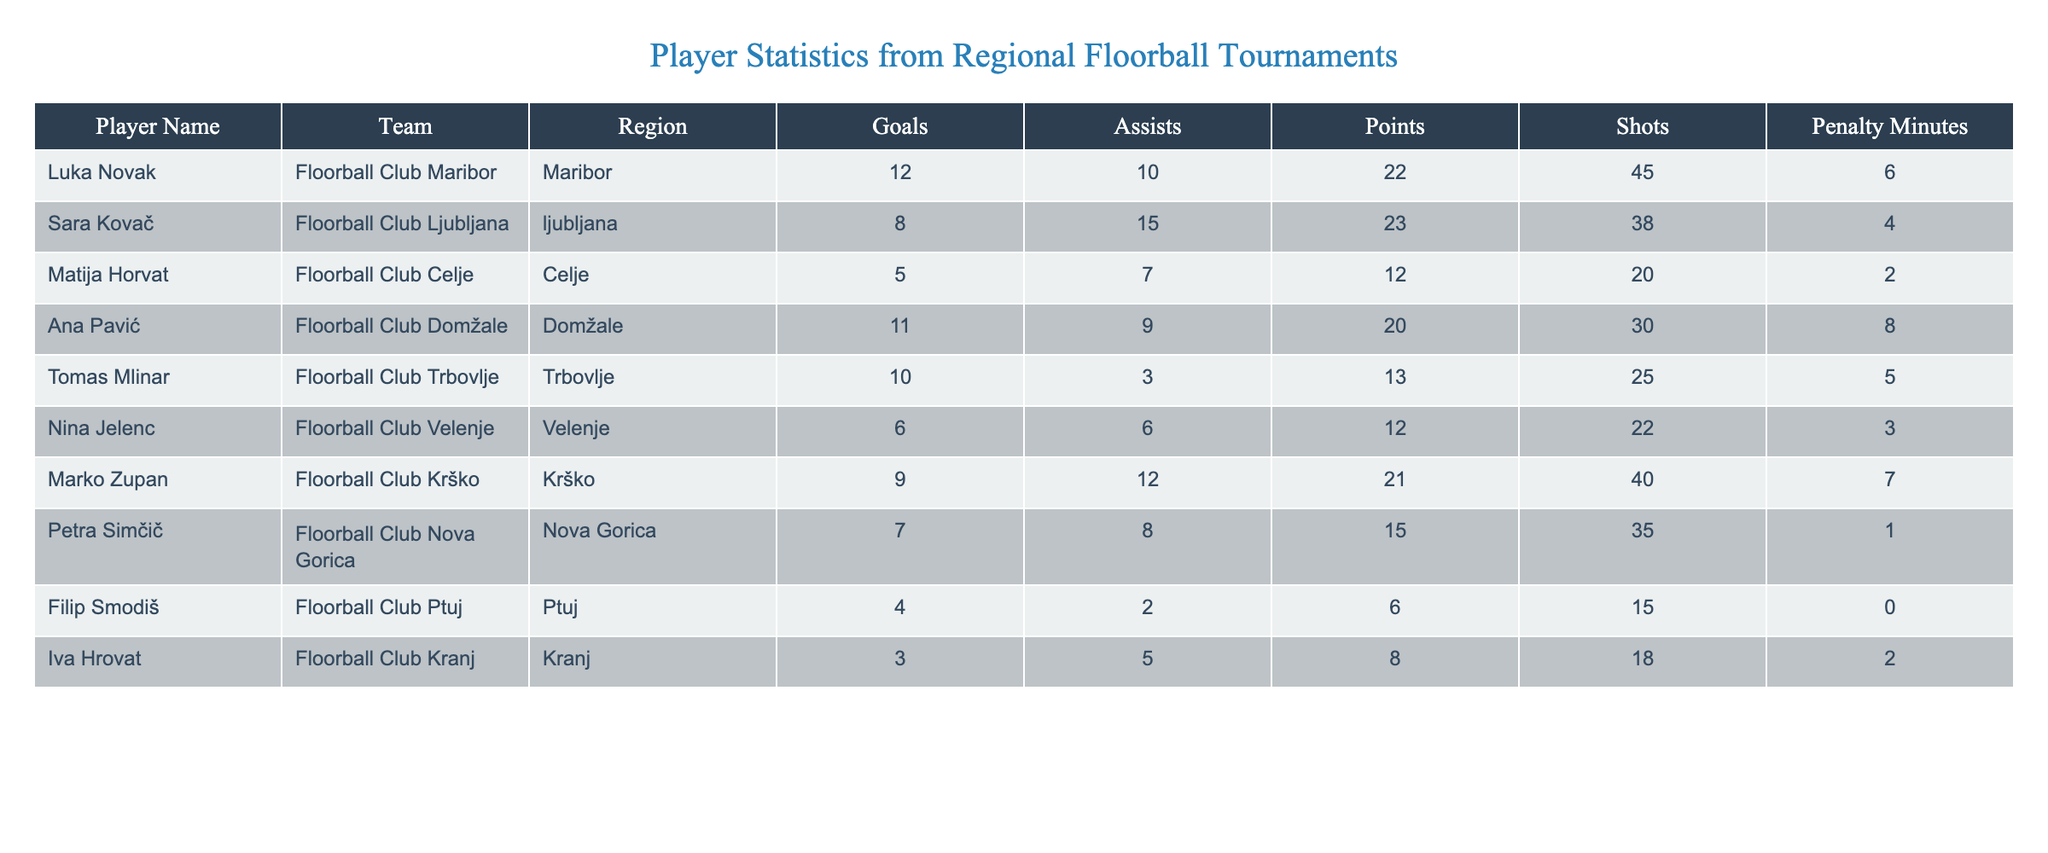What is the highest number of goals scored by a player? Luka Novak scored the highest number of goals, which is 12. This can be verified by examining the "Goals" column in the table.
Answer: 12 Who has the most assists in the tournament? Sara Kovač has the highest number of assists with a total of 15, as seen in the "Assists" column.
Answer: 15 What is the total points scored by players from Floorball Club Maribor? To find the total points for Floorball Club Maribor, we look at Luka Novak's points, which is 22. As he is the only player from this club in the data, the total points are simply 22.
Answer: 22 Which player has the highest penalty minutes, and how many do they have? Marko Zupan has the highest penalty minutes at 7. This is found by scanning the "Penalty Minutes" column for the maximum value.
Answer: 7 Is it true that Ana Pavić scored more points than Tomas Mlinar? Yes, Ana Pavić scored 20 points, while Tomas Mlinar scored 13 points. Comparing these two values shows that Ana Pavić has more points.
Answer: Yes What is the average number of shots taken by players in the tournament? To calculate the average number of shots, we sum the shots taken by all players: 45 + 38 + 20 + 30 + 25 + 22 + 40 + 35 + 15 + 18 = 338. There are 10 players, so the average is 338/10 = 33.8.
Answer: 33.8 How many players scored more than 10 points? There are 5 players with more than 10 points: Luka Novak (22), Sara Kovač (23), Ana Pavić (20), Marko Zupan (21), and Petar Simčič (15). Therefore, the count is 5.
Answer: 5 What region does Filip Smodiš come from, and how many assists did he have? Filip Smodiš is from the "Ptuj" region and he had 2 assists, both of which are reported in the respective columns.
Answer: Ptuj, 2 Which player scored the least number of goals, and what was that number? Filip Smodiš scored the least number of goals, totaling 4. This is determined by finding the minimum value in the "Goals" column.
Answer: 4 What is the difference in total points between the player with the highest and lowest points? Luka Novak has the highest total points at 22, while Filip Smodiš has the lowest at 6. The difference is 22 - 6 = 16.
Answer: 16 